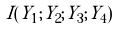<formula> <loc_0><loc_0><loc_500><loc_500>I ( Y _ { 1 } ; Y _ { 2 } ; Y _ { 3 } ; Y _ { 4 } )</formula> 